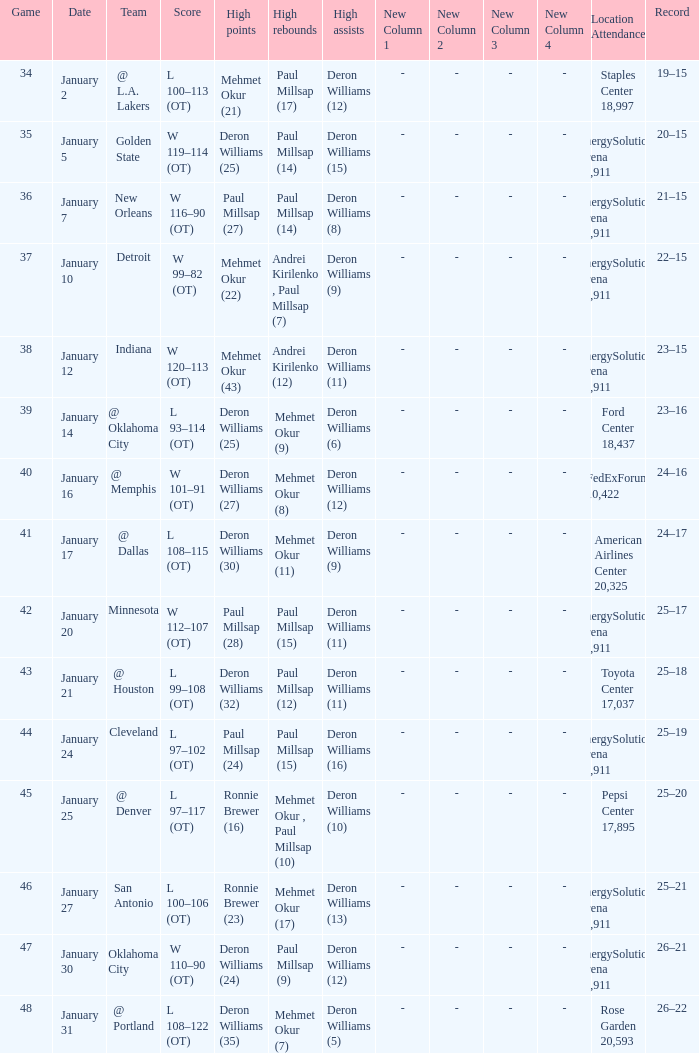What was the score of Game 48? L 108–122 (OT). 